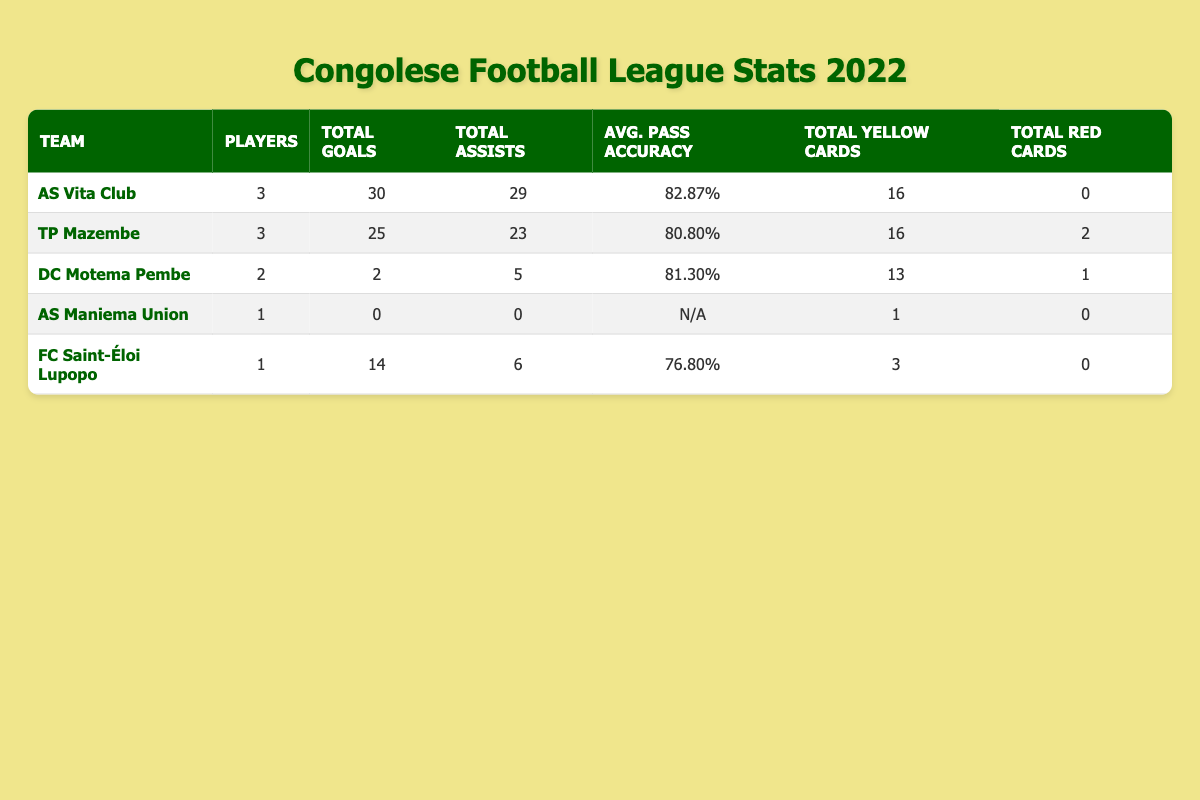What is the total number of goals scored by players from AS Vita Club? To find the total goals scored by players from AS Vita Club, we look at the "Total Goals" column for that team, which shows 30.
Answer: 30 Which team has the highest average pass accuracy? We can check the "Avg. Pass Accuracy" for each team. AS Vita Club has 82.87%, TP Mazembe has 80.80%, DC Motema Pembe has 81.30%, AS Maniema Union has N/A, and FC Saint-Éloi Lupopo has 76.80%. AS Vita Club has the highest value.
Answer: AS Vita Club How many assists did players from TP Mazembe collectively make? The "Total Assists" for TP Mazembe is listed as 23 in the table.
Answer: 23 Did FC Saint-Éloi Lupopo receive any red cards? We can check the "Total Red Cards" for FC Saint-Éloi Lupopo in the table, which shows 0. Therefore, they did not receive any red cards.
Answer: No What is the difference in the total goals scored between AS Vita Club and TP Mazembe? The total goals for AS Vita Club is 30, and for TP Mazembe, it is 25. To find the difference, we subtract 25 from 30, which equals 5.
Answer: 5 Which player or players contributed to the total of 29 assists for AS Vita Club? In total, 3 players contributed to 29 assists: Emmanuel Ilunga with 8, Josué Kazadi with 10, and Mukoko Tonombe with 11. The sum is 8 + 10 + 11 = 29.
Answer: Emmanuel Ilunga, Josué Kazadi, Mukoko Tonombe Is it true that DC Motema Pembe received the highest number of yellow cards? Checking the "Total Yellow Cards" column, DC Motema Pembe has 13, while AS Vita Club has 16, TP Mazembe has 16, and others have lower counts. So it is false that DC Motema Pembe has the highest.
Answer: No How many total players contributed from the team that had the most yellow cards? From the table, both AS Vita Club and TP Mazembe had 16 yellow cards, but AS Vita Club has 3 players, and TP Mazembe has 3. Therefore, they both contributed equally with 3 players each.
Answer: 3 What is the combined total of yellow and red cards for each team? We will add the "Total Yellow Cards" and "Total Red Cards" for each team. For AS Vita Club: 16 + 0 = 16, TP Mazembe: 16 + 2 = 18, DC Motema Pembe: 13 + 1 = 14, AS Maniema Union: 1 + 0 = 1, FC Saint-Éloi Lupopo: 3 + 0 = 3.
Answer: AS Vita Club has 16, TP Mazembe 18, DC Motema Pembe 14, AS Maniema Union 1, FC Saint-Éloi Lupopo 3 